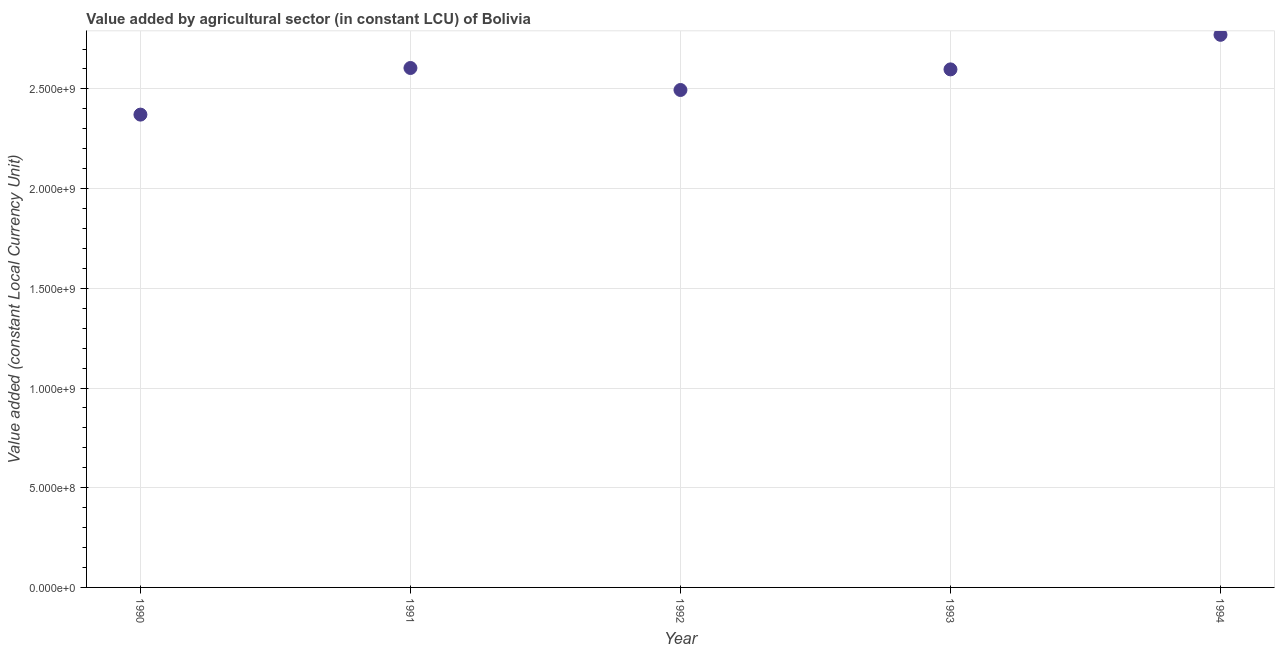What is the value added by agriculture sector in 1994?
Keep it short and to the point. 2.77e+09. Across all years, what is the maximum value added by agriculture sector?
Keep it short and to the point. 2.77e+09. Across all years, what is the minimum value added by agriculture sector?
Provide a succinct answer. 2.37e+09. In which year was the value added by agriculture sector minimum?
Ensure brevity in your answer.  1990. What is the sum of the value added by agriculture sector?
Provide a short and direct response. 1.28e+1. What is the difference between the value added by agriculture sector in 1990 and 1994?
Ensure brevity in your answer.  -4.00e+08. What is the average value added by agriculture sector per year?
Your answer should be compact. 2.57e+09. What is the median value added by agriculture sector?
Ensure brevity in your answer.  2.60e+09. What is the ratio of the value added by agriculture sector in 1992 to that in 1994?
Provide a succinct answer. 0.9. Is the value added by agriculture sector in 1992 less than that in 1993?
Make the answer very short. Yes. What is the difference between the highest and the second highest value added by agriculture sector?
Provide a short and direct response. 1.66e+08. What is the difference between the highest and the lowest value added by agriculture sector?
Provide a short and direct response. 4.00e+08. In how many years, is the value added by agriculture sector greater than the average value added by agriculture sector taken over all years?
Keep it short and to the point. 3. Does the value added by agriculture sector monotonically increase over the years?
Your response must be concise. No. How many dotlines are there?
Provide a short and direct response. 1. How many years are there in the graph?
Ensure brevity in your answer.  5. What is the difference between two consecutive major ticks on the Y-axis?
Keep it short and to the point. 5.00e+08. Does the graph contain any zero values?
Your response must be concise. No. Does the graph contain grids?
Your answer should be compact. Yes. What is the title of the graph?
Make the answer very short. Value added by agricultural sector (in constant LCU) of Bolivia. What is the label or title of the Y-axis?
Give a very brief answer. Value added (constant Local Currency Unit). What is the Value added (constant Local Currency Unit) in 1990?
Ensure brevity in your answer.  2.37e+09. What is the Value added (constant Local Currency Unit) in 1991?
Your answer should be compact. 2.60e+09. What is the Value added (constant Local Currency Unit) in 1992?
Offer a terse response. 2.49e+09. What is the Value added (constant Local Currency Unit) in 1993?
Your answer should be very brief. 2.60e+09. What is the Value added (constant Local Currency Unit) in 1994?
Your answer should be compact. 2.77e+09. What is the difference between the Value added (constant Local Currency Unit) in 1990 and 1991?
Offer a very short reply. -2.34e+08. What is the difference between the Value added (constant Local Currency Unit) in 1990 and 1992?
Your response must be concise. -1.23e+08. What is the difference between the Value added (constant Local Currency Unit) in 1990 and 1993?
Give a very brief answer. -2.27e+08. What is the difference between the Value added (constant Local Currency Unit) in 1990 and 1994?
Provide a succinct answer. -4.00e+08. What is the difference between the Value added (constant Local Currency Unit) in 1991 and 1992?
Offer a terse response. 1.10e+08. What is the difference between the Value added (constant Local Currency Unit) in 1991 and 1993?
Offer a terse response. 6.96e+06. What is the difference between the Value added (constant Local Currency Unit) in 1991 and 1994?
Offer a terse response. -1.66e+08. What is the difference between the Value added (constant Local Currency Unit) in 1992 and 1993?
Keep it short and to the point. -1.03e+08. What is the difference between the Value added (constant Local Currency Unit) in 1992 and 1994?
Provide a short and direct response. -2.77e+08. What is the difference between the Value added (constant Local Currency Unit) in 1993 and 1994?
Offer a very short reply. -1.73e+08. What is the ratio of the Value added (constant Local Currency Unit) in 1990 to that in 1991?
Your response must be concise. 0.91. What is the ratio of the Value added (constant Local Currency Unit) in 1990 to that in 1992?
Your response must be concise. 0.95. What is the ratio of the Value added (constant Local Currency Unit) in 1990 to that in 1993?
Make the answer very short. 0.91. What is the ratio of the Value added (constant Local Currency Unit) in 1990 to that in 1994?
Give a very brief answer. 0.86. What is the ratio of the Value added (constant Local Currency Unit) in 1991 to that in 1992?
Make the answer very short. 1.04. What is the ratio of the Value added (constant Local Currency Unit) in 1992 to that in 1993?
Your answer should be compact. 0.96. What is the ratio of the Value added (constant Local Currency Unit) in 1992 to that in 1994?
Your answer should be very brief. 0.9. What is the ratio of the Value added (constant Local Currency Unit) in 1993 to that in 1994?
Provide a short and direct response. 0.94. 